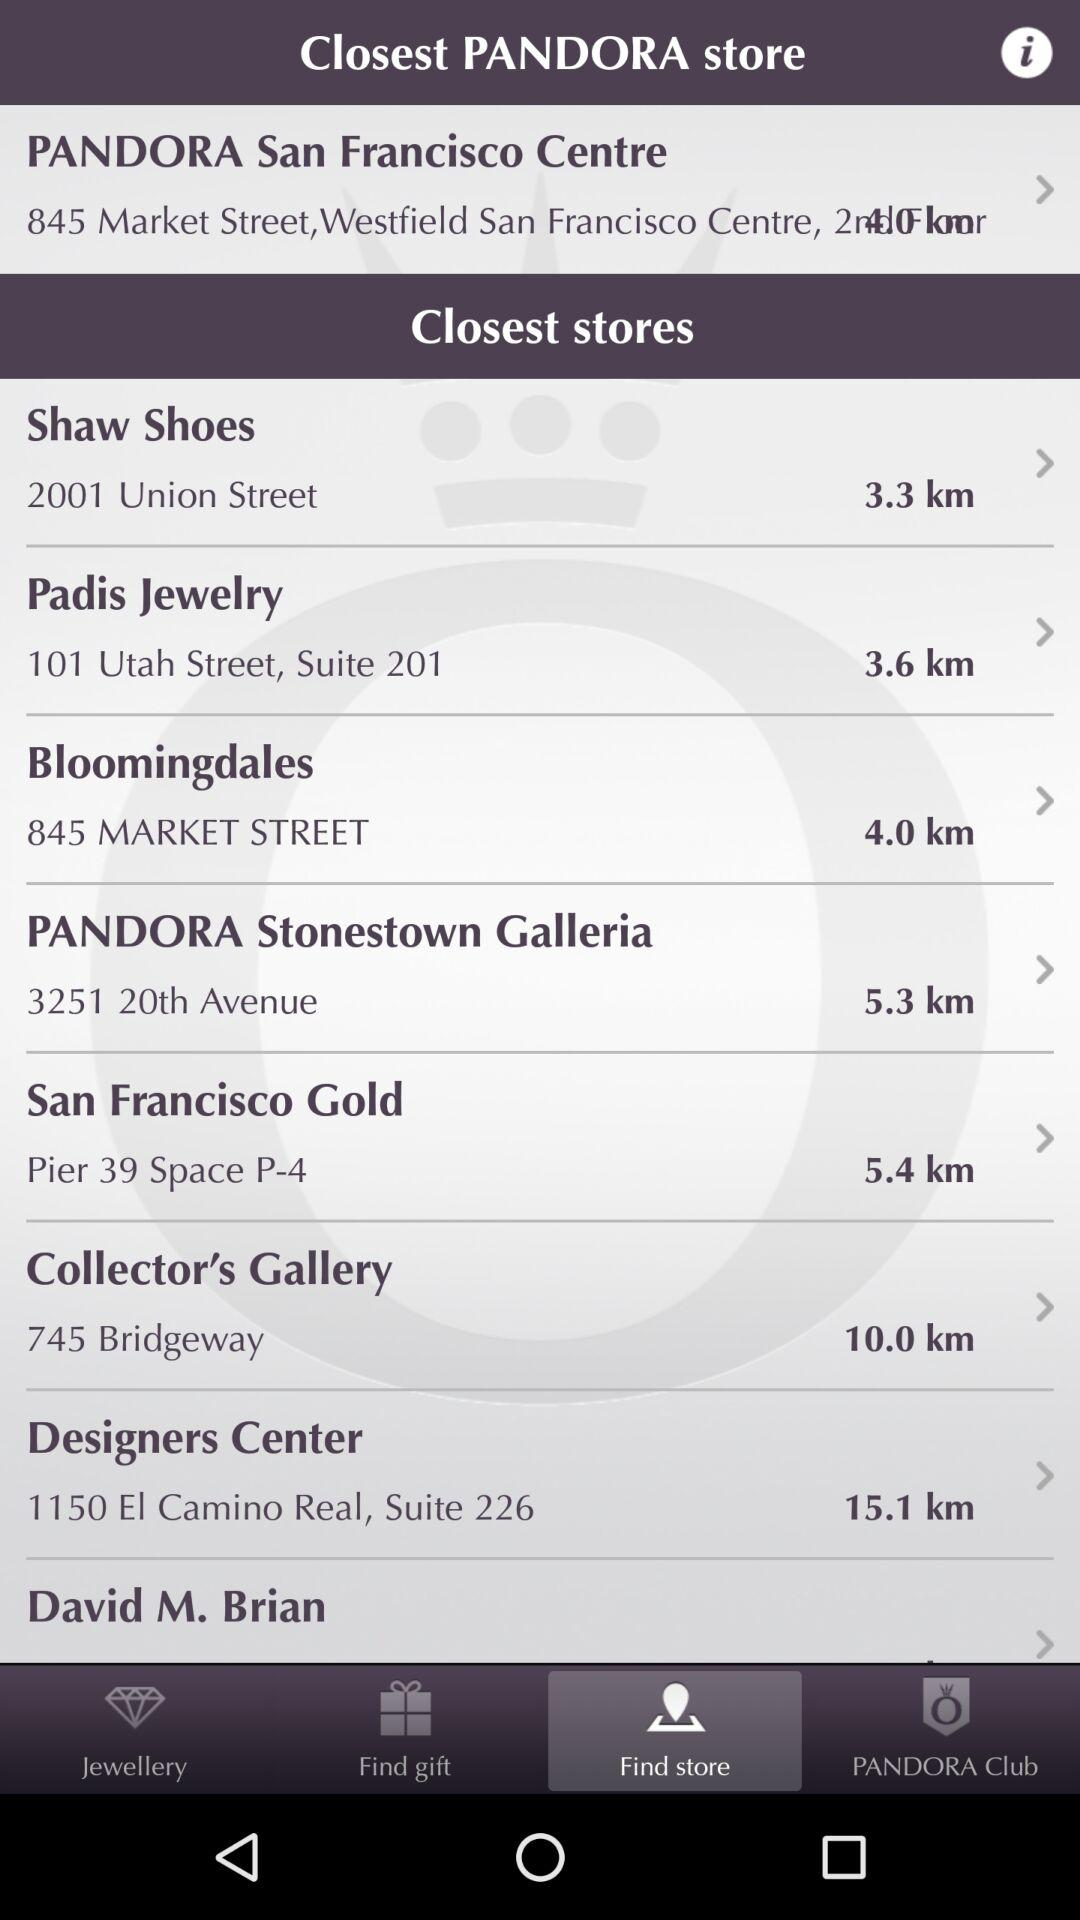What is the distance of PANDORA San Francisco Centre?
When the provided information is insufficient, respond with <no answer>. <no answer> 